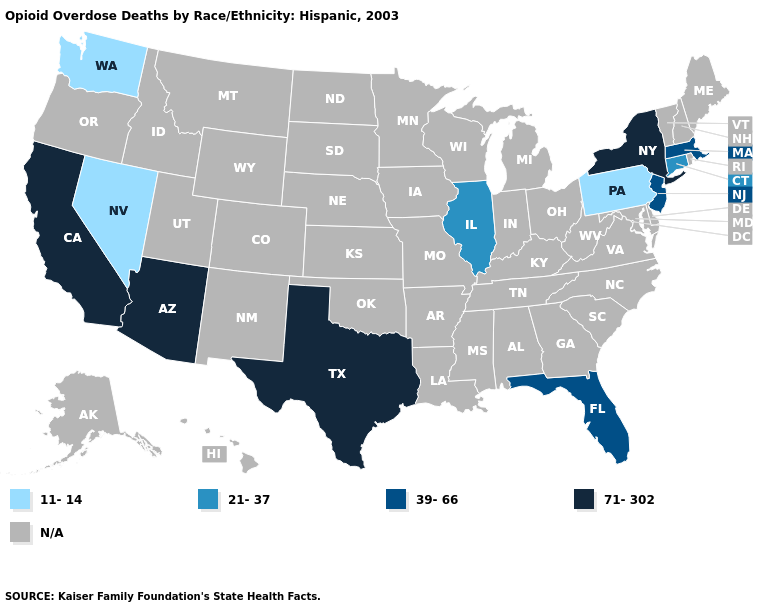Name the states that have a value in the range 11-14?
Concise answer only. Nevada, Pennsylvania, Washington. Which states have the highest value in the USA?
Be succinct. Arizona, California, New York, Texas. Is the legend a continuous bar?
Keep it brief. No. Name the states that have a value in the range N/A?
Quick response, please. Alabama, Alaska, Arkansas, Colorado, Delaware, Georgia, Hawaii, Idaho, Indiana, Iowa, Kansas, Kentucky, Louisiana, Maine, Maryland, Michigan, Minnesota, Mississippi, Missouri, Montana, Nebraska, New Hampshire, New Mexico, North Carolina, North Dakota, Ohio, Oklahoma, Oregon, Rhode Island, South Carolina, South Dakota, Tennessee, Utah, Vermont, Virginia, West Virginia, Wisconsin, Wyoming. Which states have the lowest value in the Northeast?
Concise answer only. Pennsylvania. What is the highest value in states that border Maryland?
Answer briefly. 11-14. Does Arizona have the lowest value in the West?
Keep it brief. No. What is the highest value in the USA?
Answer briefly. 71-302. What is the value of Colorado?
Short answer required. N/A. Which states have the lowest value in the South?
Short answer required. Florida. Does Pennsylvania have the lowest value in the USA?
Keep it brief. Yes. 